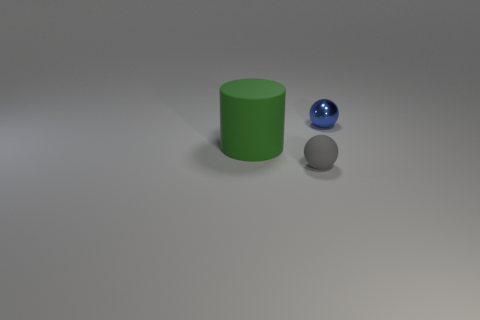What might the textures of these objects be like? The green cylinder has a smooth and matte finish, while the blue sphere seems to have a glossy surface, reflecting light. The gray object appears to have a rough, diffuse surface, possibly like stone or concrete. 